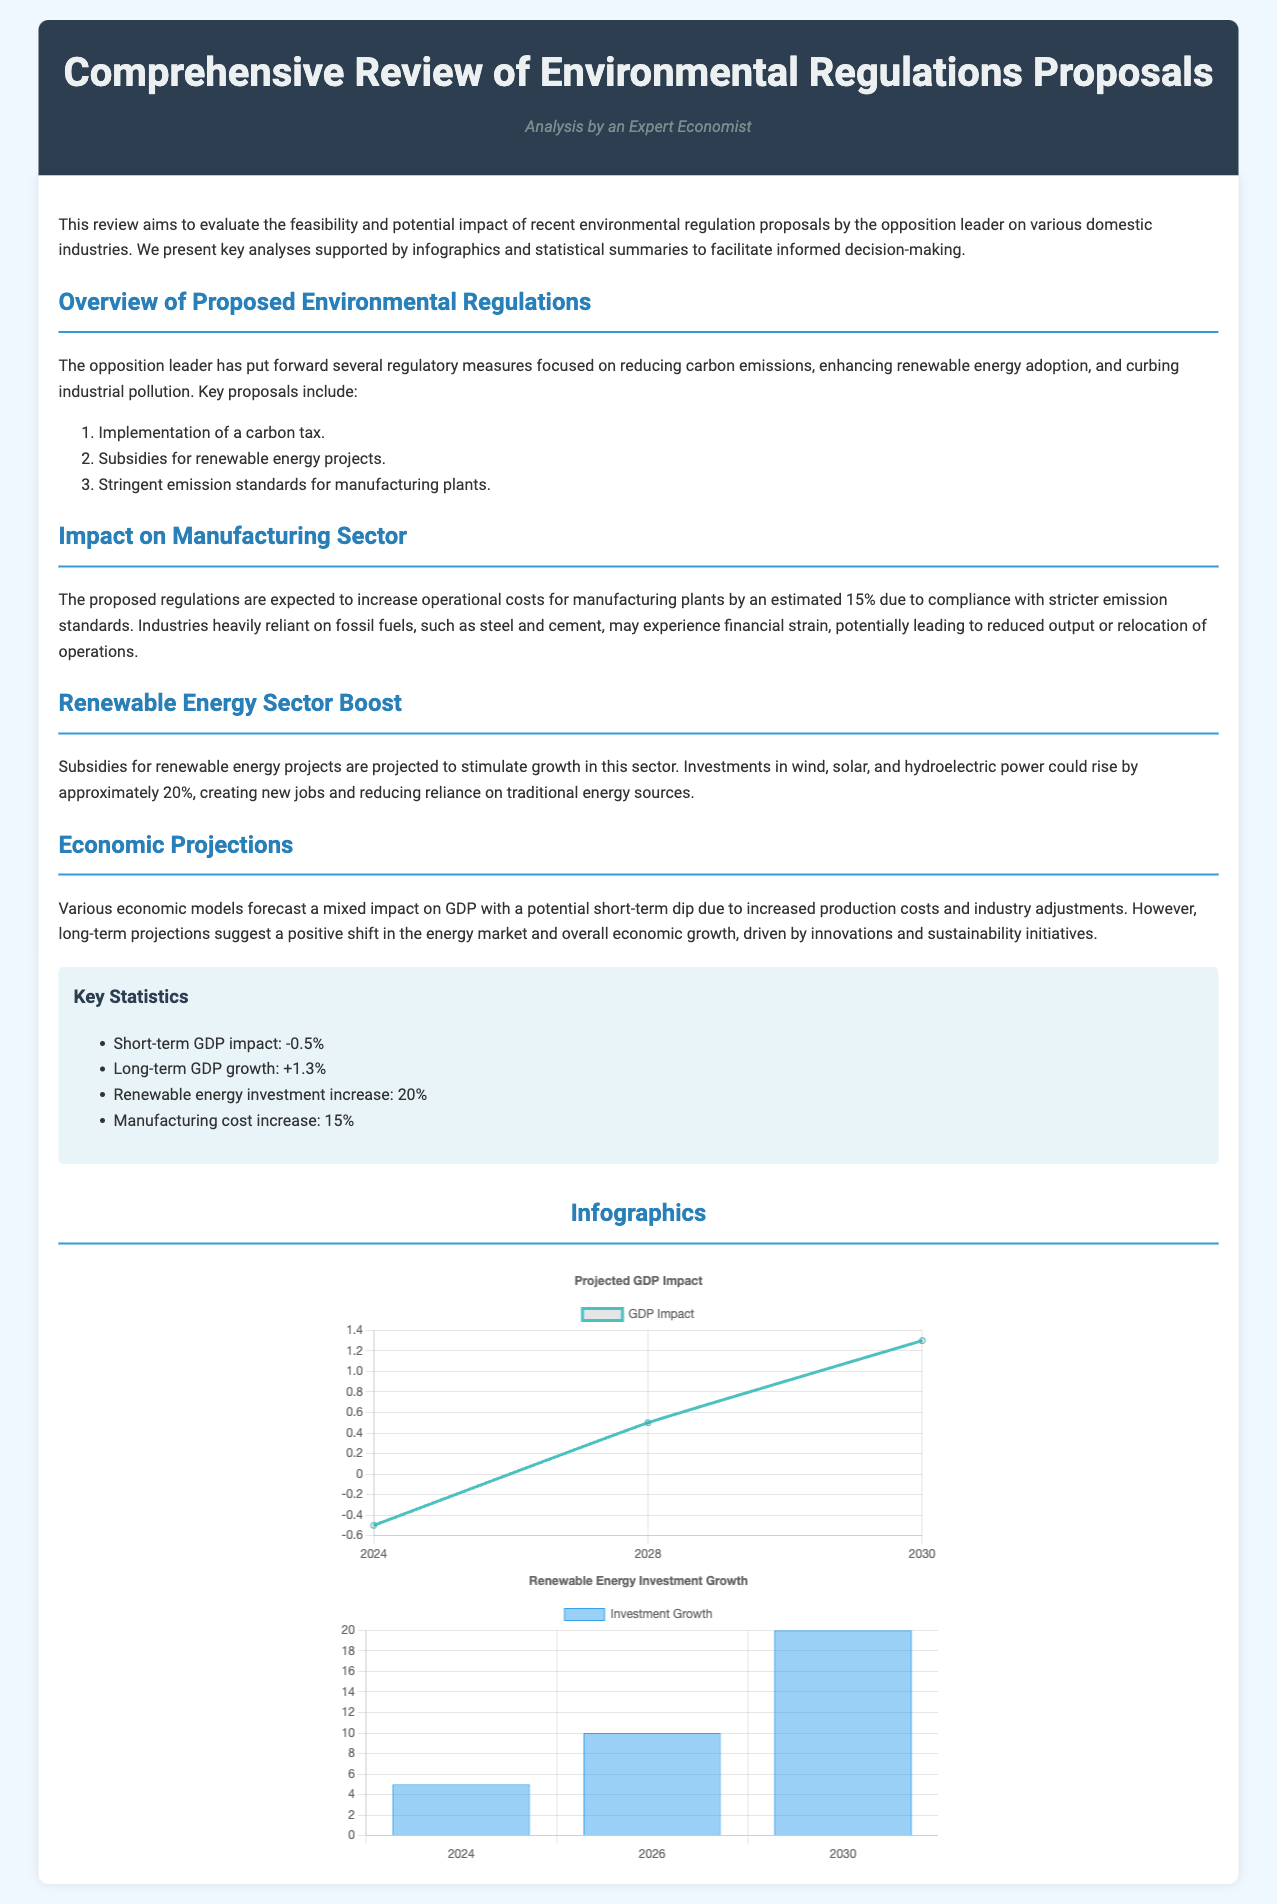What is the primary focus of the opposition leader's proposals? The proposals focus on reducing carbon emissions, enhancing renewable energy adoption, and curbing industrial pollution.
Answer: Reducing carbon emissions What is the projected increase in operational costs for manufacturing plants? The document states that operational costs for manufacturing plants are expected to increase by approximately 15% due to compliance with stricter emission standards.
Answer: 15% What is the anticipated short-term impact on GDP? The document mentions a short-term dip in GDP due to increased production costs and industry adjustments, specifically highlighting a -0.5% impact.
Answer: -0.5% How much is the expected increase in renewable energy investments? The document indicates that investments in renewable energy projects are projected to rise by approximately 20%.
Answer: 20% What are the three main proposals mentioned? The proposals include implementation of a carbon tax, subsidies for renewable energy projects, and stringent emission standards for manufacturing plants.
Answer: Carbon tax, subsidies for renewable energy, stringent emission standards What is the long-term GDP growth projection? The document forecasts a long-term GDP growth of +1.3% as a result of sustainability initiatives.
Answer: +1.3% What is the percentage increase in renewable energy investment by 2030? The investment growth in renewable energy is projected to be 20% by 2030.
Answer: 20% Which sectors are anticipated to experience financial strain due to the proposed regulations? The sectors that may experience financial strain are heavily reliant on fossil fuels, such as steel and cement.
Answer: Steel and cement How many charts are included in the infographic section? The infographic section includes two charts related to GDP impact and renewable energy investment growth.
Answer: Two 